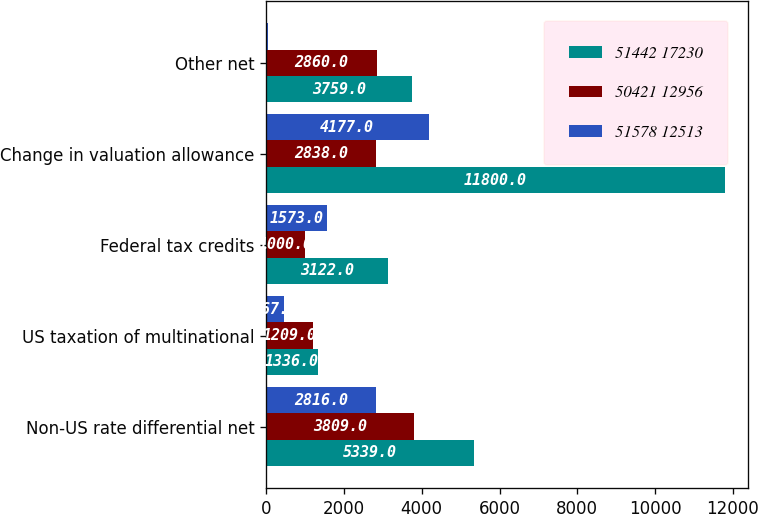Convert chart. <chart><loc_0><loc_0><loc_500><loc_500><stacked_bar_chart><ecel><fcel>Non-US rate differential net<fcel>US taxation of multinational<fcel>Federal tax credits<fcel>Change in valuation allowance<fcel>Other net<nl><fcel>51442 17230<fcel>5339<fcel>1336<fcel>3122<fcel>11800<fcel>3759<nl><fcel>50421 12956<fcel>3809<fcel>1209<fcel>1000<fcel>2838<fcel>2860<nl><fcel>51578 12513<fcel>2816<fcel>467<fcel>1573<fcel>4177<fcel>51<nl></chart> 